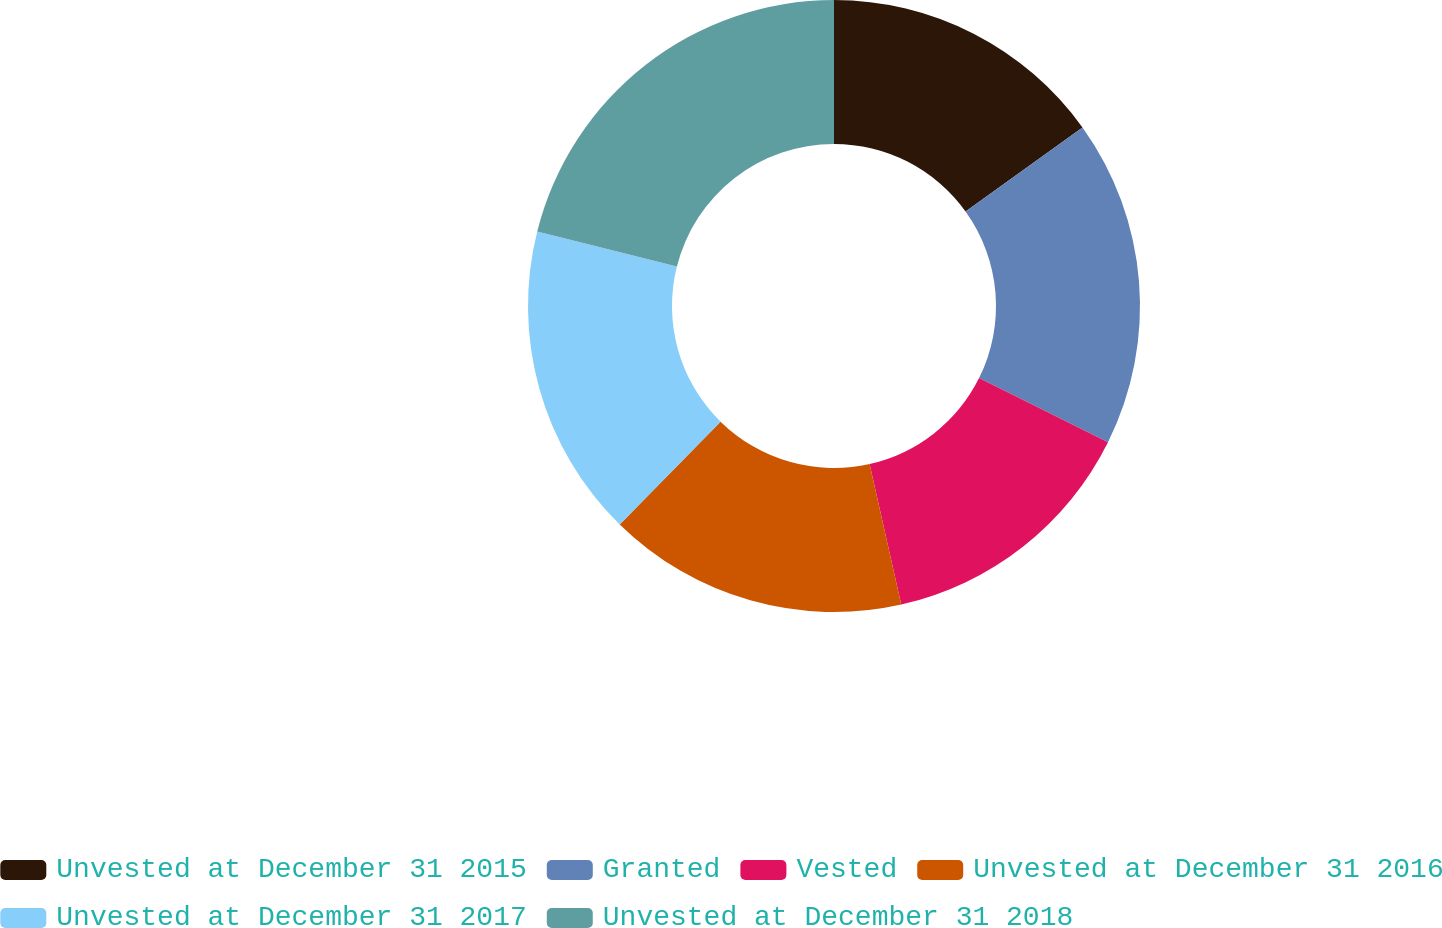<chart> <loc_0><loc_0><loc_500><loc_500><pie_chart><fcel>Unvested at December 31 2015<fcel>Granted<fcel>Vested<fcel>Unvested at December 31 2016<fcel>Unvested at December 31 2017<fcel>Unvested at December 31 2018<nl><fcel>15.08%<fcel>17.26%<fcel>14.13%<fcel>15.87%<fcel>16.57%<fcel>21.08%<nl></chart> 